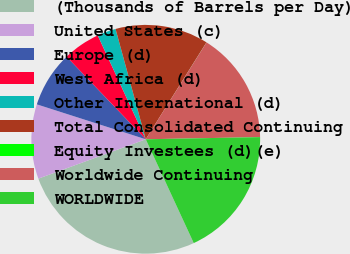Convert chart. <chart><loc_0><loc_0><loc_500><loc_500><pie_chart><fcel>(Thousands of Barrels per Day)<fcel>United States (c)<fcel>Europe (d)<fcel>West Africa (d)<fcel>Other International (d)<fcel>Total Consolidated Continuing<fcel>Equity Investees (d)(e)<fcel>Worldwide Continuing<fcel>WORLDWIDE<nl><fcel>26.3%<fcel>10.53%<fcel>7.9%<fcel>5.27%<fcel>2.64%<fcel>13.16%<fcel>0.01%<fcel>15.78%<fcel>18.41%<nl></chart> 